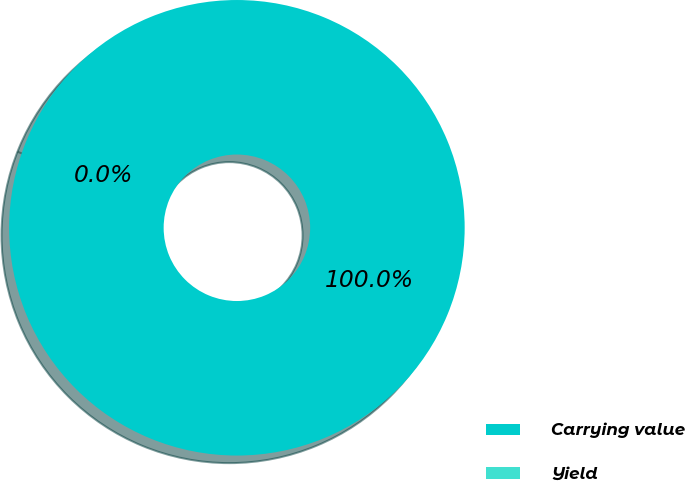Convert chart. <chart><loc_0><loc_0><loc_500><loc_500><pie_chart><fcel>Carrying value<fcel>Yield<nl><fcel>100.0%<fcel>0.0%<nl></chart> 